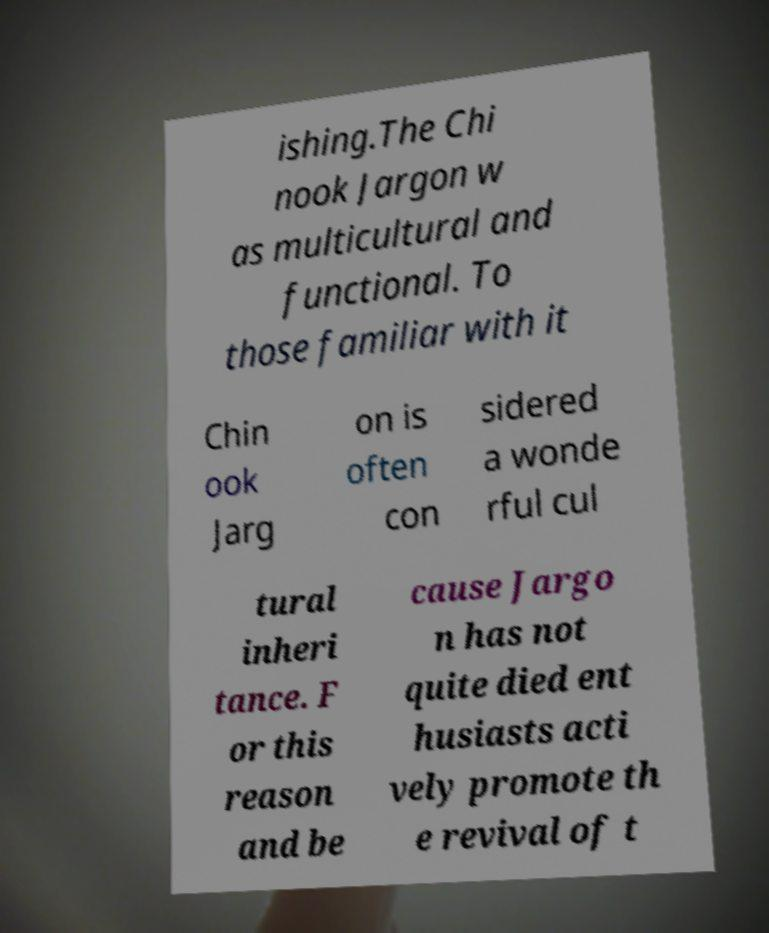Please identify and transcribe the text found in this image. ishing.The Chi nook Jargon w as multicultural and functional. To those familiar with it Chin ook Jarg on is often con sidered a wonde rful cul tural inheri tance. F or this reason and be cause Jargo n has not quite died ent husiasts acti vely promote th e revival of t 